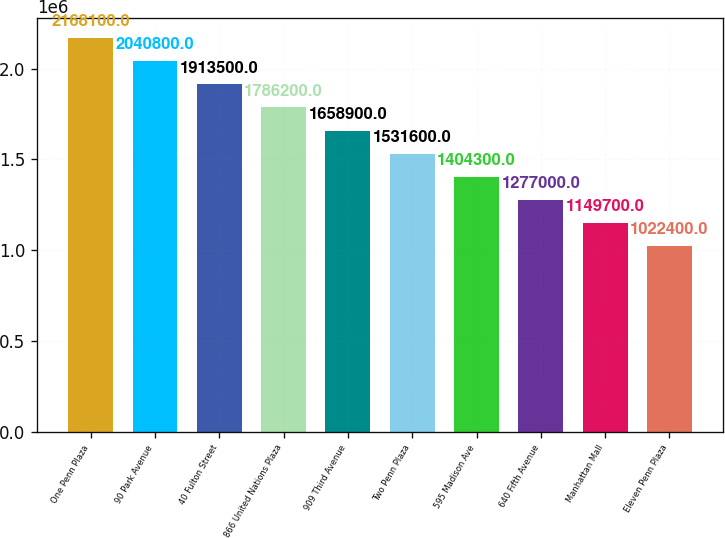Convert chart to OTSL. <chart><loc_0><loc_0><loc_500><loc_500><bar_chart><fcel>One Penn Plaza<fcel>90 Park Avenue<fcel>40 Fulton Street<fcel>866 United Nations Plaza<fcel>909 Third Avenue<fcel>Two Penn Plaza<fcel>595 Madison Ave<fcel>640 Fifth Avenue<fcel>Manhattan Mall<fcel>Eleven Penn Plaza<nl><fcel>2.1681e+06<fcel>2.0408e+06<fcel>1.9135e+06<fcel>1.7862e+06<fcel>1.6589e+06<fcel>1.5316e+06<fcel>1.4043e+06<fcel>1.277e+06<fcel>1.1497e+06<fcel>1.0224e+06<nl></chart> 